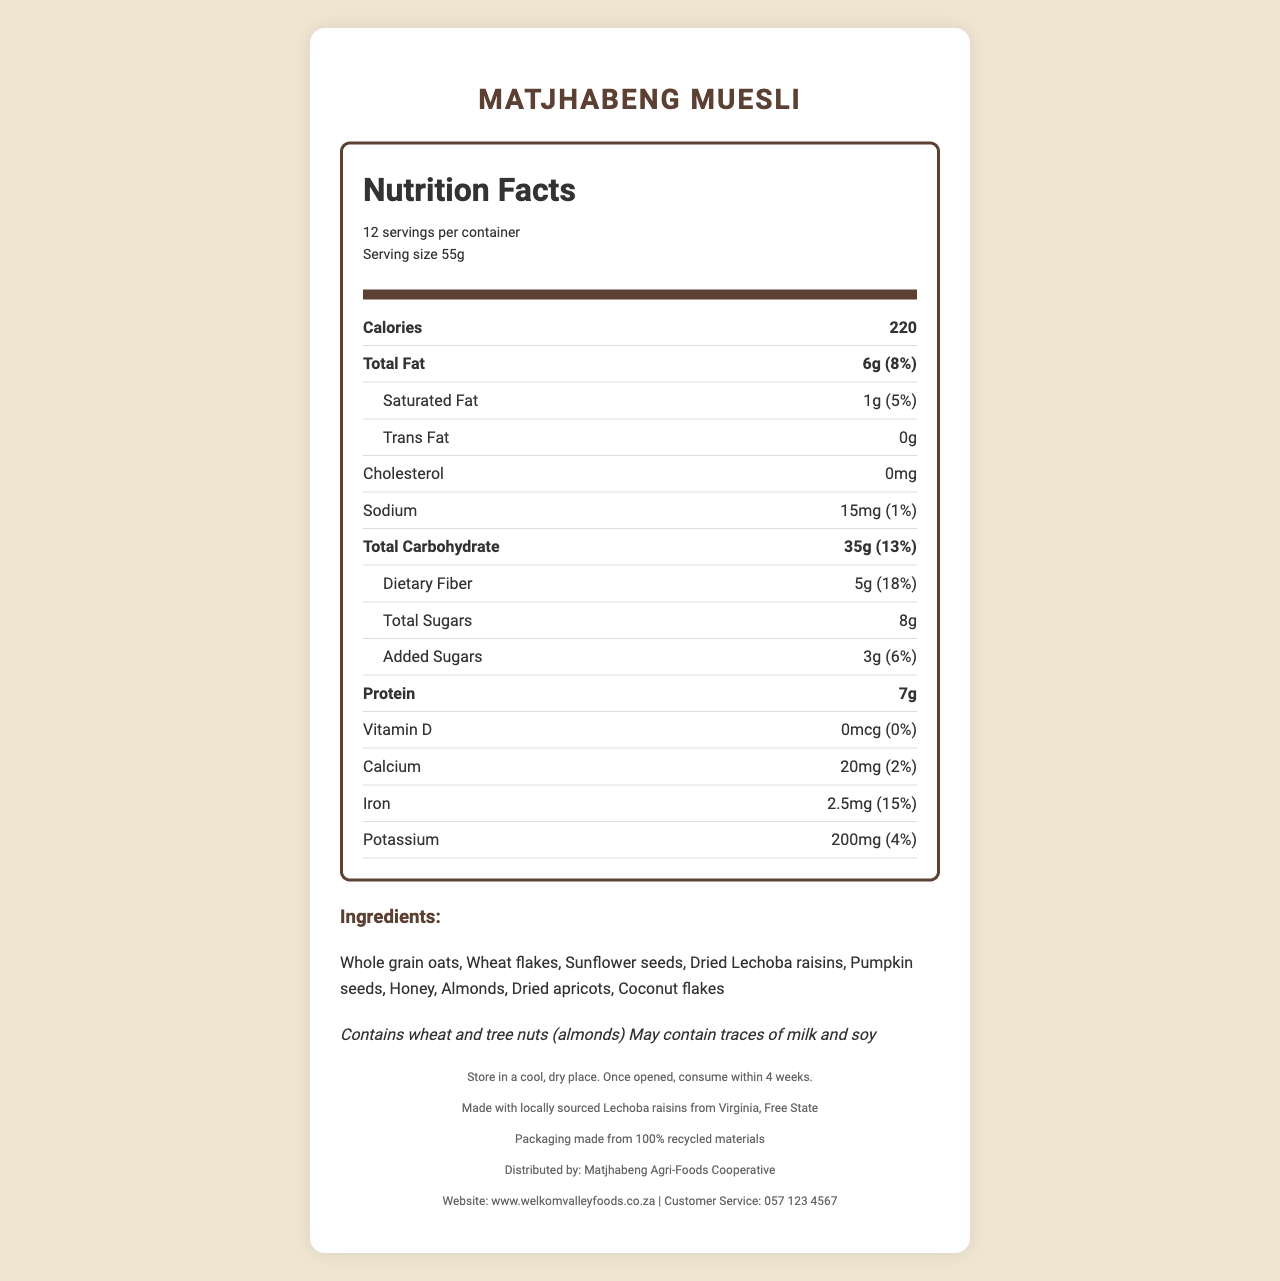what is the serving size of Matjhabeng Muesli? The serving size is mentioned in the nutrition header under "serving size."
Answer: 55g how many servings are there per container? The number of servings per container is mentioned in the nutrition header as "12 servings per container."
Answer: 12 what is the calorie content per serving? The calorie content per serving is listed prominently in the nutrition facts section under "Calories."
Answer: 220 how much total fat is in one serving? The total fat content is listed as 6g in the nutrition facts section.
Answer: 6g what percentage of the daily value for dietary fiber does one serving provide? The daily value percentage for dietary fiber is listed next to its amount (5g) in the nutrition facts section.
Answer: 18% how many grams of protein are in one serving? The amount of protein per serving is mentioned in the nutrition facts section.
Answer: 7g how much iron does one serving of Matjhabeng Muesli contain? The amount of iron per serving is mentioned in the nutrition facts section.
Answer: 2.5mg what is the main ingredient in Matjhabeng Muesli? The ingredients list starts with "Whole grain oats," indicating it is the main ingredient.
Answer: Whole grain oats what is the amount of calcium per serving? The amount of calcium per serving is listed in the nutrition facts section.
Answer: 20mg what should you do once the product is opened? A. Store in a refrigerator B. Consume within 4 weeks C. Freeze it right away D. Consume within 2 weeks The storage instructions state, "Once opened, consume within 4 weeks."
Answer: B which ingredient in Matjhabeng Muesli is locally sourced? A. Almonds B. Honey C. Lechoba raisins D. Pumpkin seeds The document states that the product is made with locally sourced Lechoba raisins from Virginia, Free State.
Answer: C where can you contact customer service for Matjhabeng Muesli? The customer service number is listed in the footer.
Answer: 057 123 4567 does Matjhabeng Muesli contain any trans fats? The nutrition facts section lists Trans Fat as 0g, indicating there are no trans fats.
Answer: No does Matjhabeng Muesli contain tree nuts? The allergens section states that the product contains tree nuts (almonds).
Answer: Yes summarize the information provided in the document about Matjhabeng Muesli. The detailed explanation consists of a comprehensive description of nutritional facts, ingredient list, potential allergens, storage guidelines, and additional information on local sourcing, sustainability, and customer service options.
Answer: The document provides detailed nutritional information about Matjhabeng Muesli, a product from Welkom Valley Foods. It outlines the serving size, calories, and amounts of various nutrients per serving. The document also lists the ingredients, potential allergens, storage instructions, the product's local connection, and sustainability notes. Contact information for customer service is also provided. Additionally, the muesli includes locally sourced Lechoba raisins and uses packaging made from recycled materials. what is the source of the wheat in Matjhabeng Muesli? The document does not provide specific information about the source of the wheat used in Matjhabeng Muesli.
Answer: Cannot be determined 